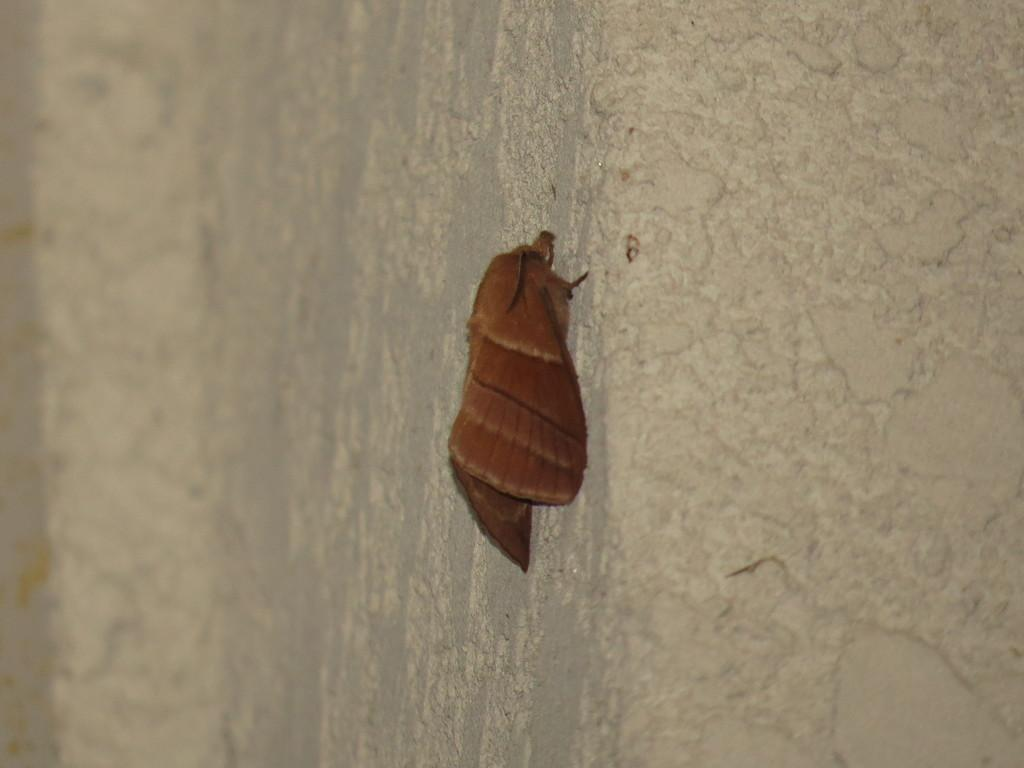What type of insect is in the image? There is a brown butterfly in the image. Where is the butterfly located? The butterfly is on the wall. What book is the butterfly reading in the image? Butterflies do not read books, as they are insects and do not have the cognitive ability to read. 